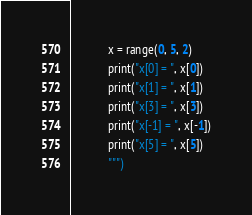<code> <loc_0><loc_0><loc_500><loc_500><_Python_>            x = range(0, 5, 2)
            print("x[0] = ", x[0])
            print("x[1] = ", x[1])
            print("x[3] = ", x[3])
            print("x[-1] = ", x[-1])
            print("x[5] = ", x[5])
            """)
</code> 